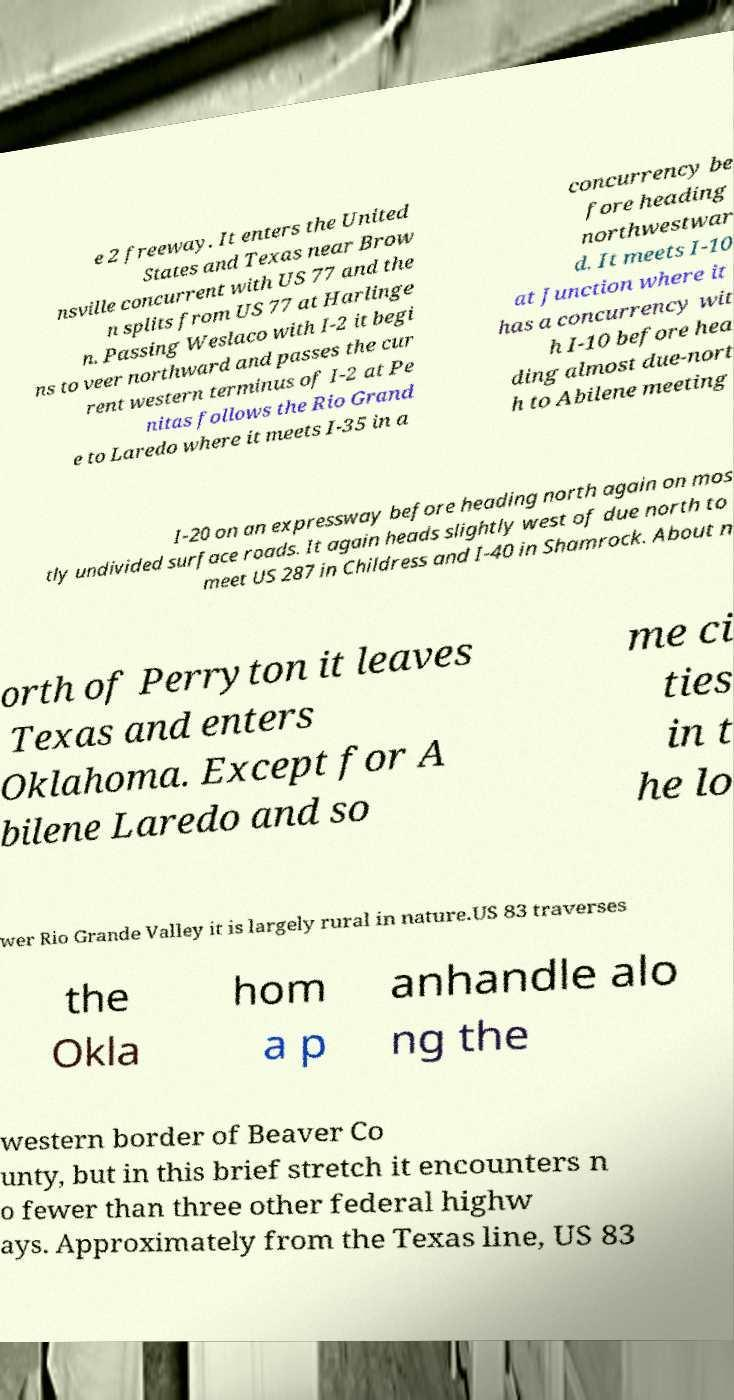Please read and relay the text visible in this image. What does it say? e 2 freeway. It enters the United States and Texas near Brow nsville concurrent with US 77 and the n splits from US 77 at Harlinge n. Passing Weslaco with I-2 it begi ns to veer northward and passes the cur rent western terminus of I-2 at Pe nitas follows the Rio Grand e to Laredo where it meets I-35 in a concurrency be fore heading northwestwar d. It meets I-10 at Junction where it has a concurrency wit h I-10 before hea ding almost due-nort h to Abilene meeting I-20 on an expressway before heading north again on mos tly undivided surface roads. It again heads slightly west of due north to meet US 287 in Childress and I-40 in Shamrock. About n orth of Perryton it leaves Texas and enters Oklahoma. Except for A bilene Laredo and so me ci ties in t he lo wer Rio Grande Valley it is largely rural in nature.US 83 traverses the Okla hom a p anhandle alo ng the western border of Beaver Co unty, but in this brief stretch it encounters n o fewer than three other federal highw ays. Approximately from the Texas line, US 83 